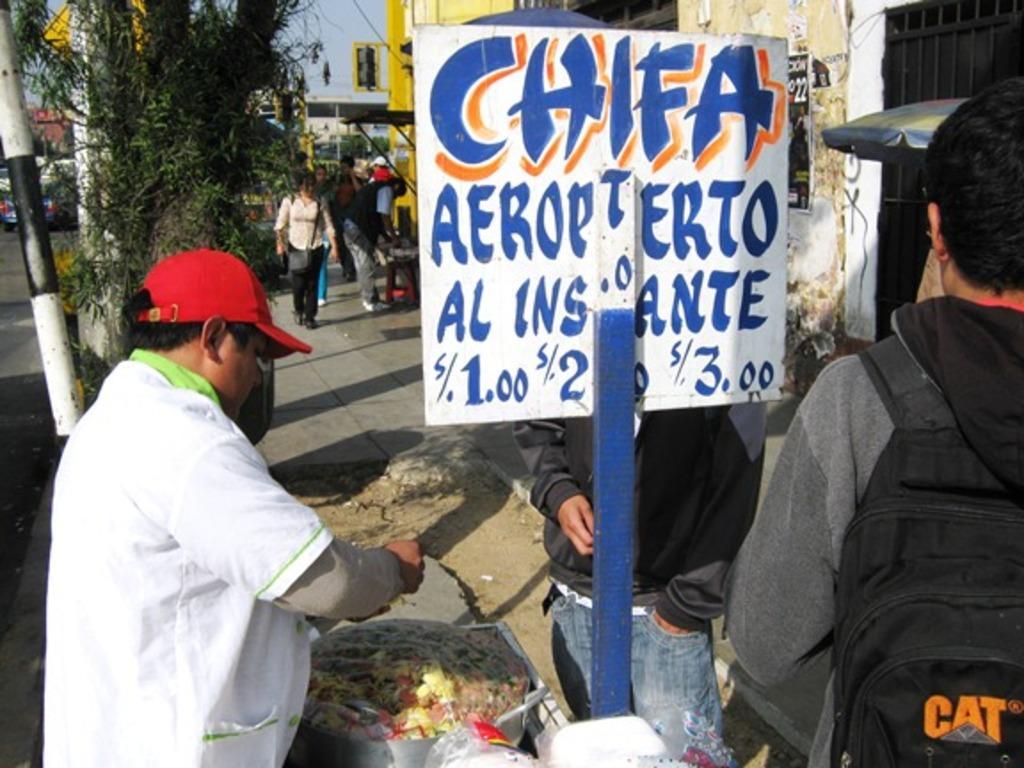How would you summarize this image in a sentence or two? At the bottom of the image few people are standing and there is a banner. Behind them there are some trees and buildings and poles and sign boards. 